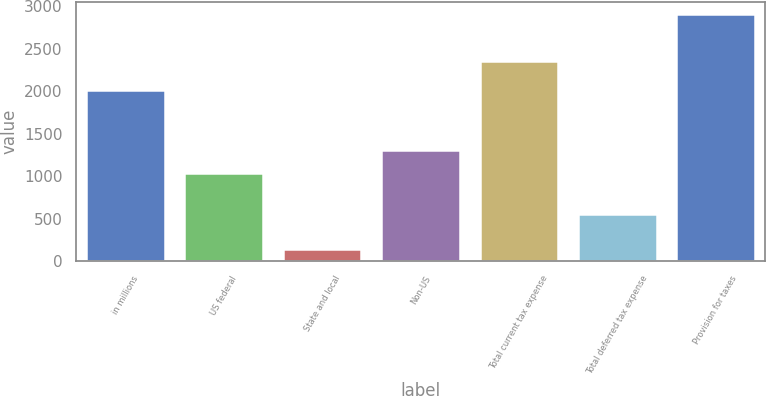Convert chart. <chart><loc_0><loc_0><loc_500><loc_500><bar_chart><fcel>in millions<fcel>US federal<fcel>State and local<fcel>Non-US<fcel>Total current tax expense<fcel>Total deferred tax expense<fcel>Provision for taxes<nl><fcel>2016<fcel>1032<fcel>139<fcel>1308.7<fcel>2355<fcel>551<fcel>2906<nl></chart> 